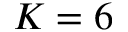Convert formula to latex. <formula><loc_0><loc_0><loc_500><loc_500>K = 6</formula> 